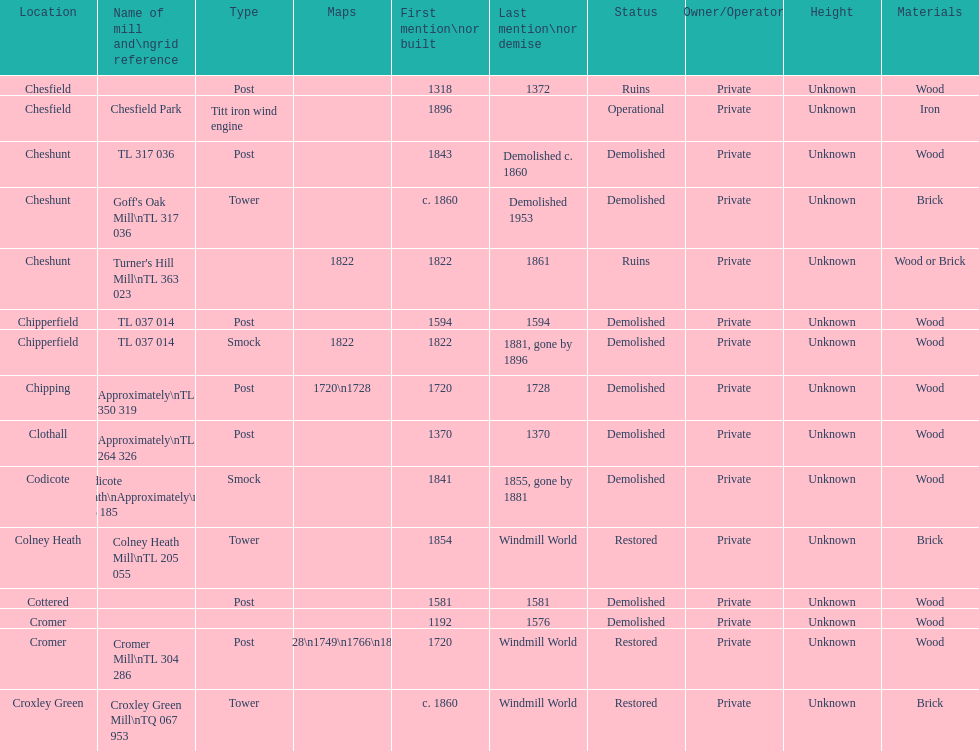What location has the most maps? Cromer. 